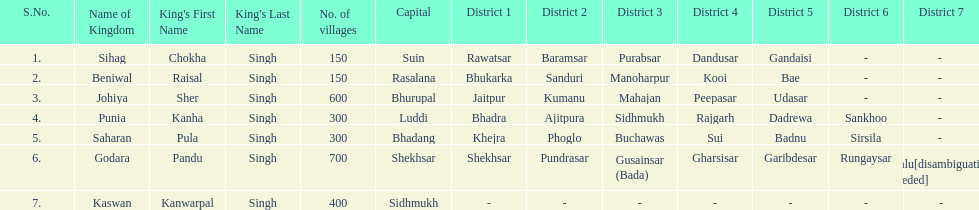Which kingdom contained the second most villages, next only to godara? Johiya. 